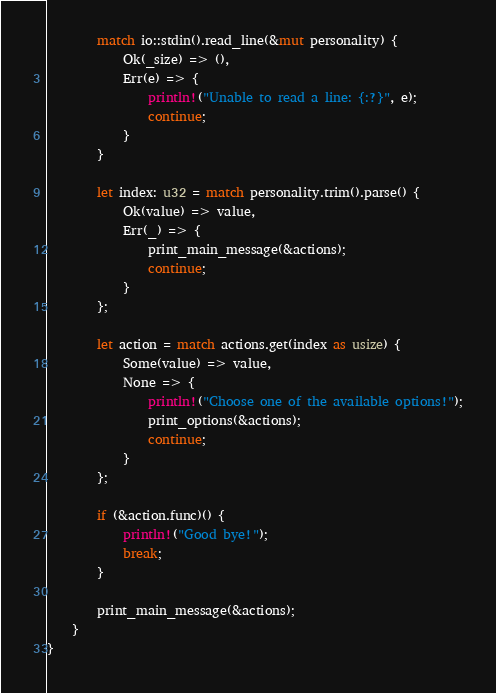Convert code to text. <code><loc_0><loc_0><loc_500><loc_500><_Rust_>        match io::stdin().read_line(&mut personality) {
            Ok(_size) => (),
            Err(e) => {
                println!("Unable to read a line: {:?}", e);
                continue;
            }
        }

        let index: u32 = match personality.trim().parse() {
            Ok(value) => value,
            Err(_) => {
                print_main_message(&actions);
                continue;
            }
        };

        let action = match actions.get(index as usize) {
            Some(value) => value,
            None => {
                println!("Choose one of the available options!");
                print_options(&actions);
                continue;
            }
        };

        if (&action.func)() {
            println!("Good bye!");
            break;
        }

        print_main_message(&actions);
    }
}
</code> 